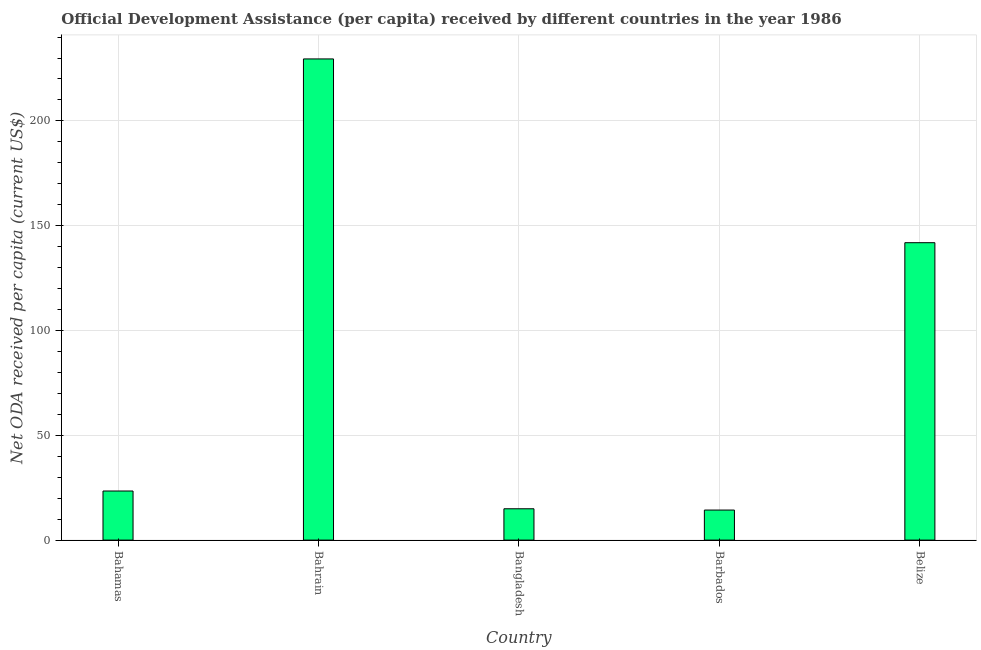Does the graph contain grids?
Your response must be concise. Yes. What is the title of the graph?
Offer a very short reply. Official Development Assistance (per capita) received by different countries in the year 1986. What is the label or title of the Y-axis?
Give a very brief answer. Net ODA received per capita (current US$). What is the net oda received per capita in Barbados?
Make the answer very short. 14.33. Across all countries, what is the maximum net oda received per capita?
Keep it short and to the point. 229.56. Across all countries, what is the minimum net oda received per capita?
Provide a succinct answer. 14.33. In which country was the net oda received per capita maximum?
Give a very brief answer. Bahrain. In which country was the net oda received per capita minimum?
Ensure brevity in your answer.  Barbados. What is the sum of the net oda received per capita?
Your answer should be compact. 424.14. What is the difference between the net oda received per capita in Bahamas and Barbados?
Ensure brevity in your answer.  9.08. What is the average net oda received per capita per country?
Give a very brief answer. 84.83. What is the median net oda received per capita?
Provide a short and direct response. 23.42. What is the ratio of the net oda received per capita in Barbados to that in Belize?
Your answer should be compact. 0.1. Is the net oda received per capita in Bangladesh less than that in Belize?
Offer a terse response. Yes. What is the difference between the highest and the second highest net oda received per capita?
Provide a short and direct response. 87.67. What is the difference between the highest and the lowest net oda received per capita?
Keep it short and to the point. 215.22. In how many countries, is the net oda received per capita greater than the average net oda received per capita taken over all countries?
Give a very brief answer. 2. How many countries are there in the graph?
Provide a succinct answer. 5. What is the difference between two consecutive major ticks on the Y-axis?
Make the answer very short. 50. Are the values on the major ticks of Y-axis written in scientific E-notation?
Provide a succinct answer. No. What is the Net ODA received per capita (current US$) of Bahamas?
Your answer should be very brief. 23.42. What is the Net ODA received per capita (current US$) in Bahrain?
Provide a short and direct response. 229.56. What is the Net ODA received per capita (current US$) of Bangladesh?
Your answer should be very brief. 14.95. What is the Net ODA received per capita (current US$) of Barbados?
Offer a very short reply. 14.33. What is the Net ODA received per capita (current US$) in Belize?
Offer a terse response. 141.89. What is the difference between the Net ODA received per capita (current US$) in Bahamas and Bahrain?
Offer a terse response. -206.14. What is the difference between the Net ODA received per capita (current US$) in Bahamas and Bangladesh?
Provide a succinct answer. 8.47. What is the difference between the Net ODA received per capita (current US$) in Bahamas and Barbados?
Make the answer very short. 9.08. What is the difference between the Net ODA received per capita (current US$) in Bahamas and Belize?
Make the answer very short. -118.47. What is the difference between the Net ODA received per capita (current US$) in Bahrain and Bangladesh?
Provide a succinct answer. 214.61. What is the difference between the Net ODA received per capita (current US$) in Bahrain and Barbados?
Offer a terse response. 215.22. What is the difference between the Net ODA received per capita (current US$) in Bahrain and Belize?
Your answer should be very brief. 87.67. What is the difference between the Net ODA received per capita (current US$) in Bangladesh and Barbados?
Offer a very short reply. 0.61. What is the difference between the Net ODA received per capita (current US$) in Bangladesh and Belize?
Your answer should be compact. -126.94. What is the difference between the Net ODA received per capita (current US$) in Barbados and Belize?
Your response must be concise. -127.55. What is the ratio of the Net ODA received per capita (current US$) in Bahamas to that in Bahrain?
Ensure brevity in your answer.  0.1. What is the ratio of the Net ODA received per capita (current US$) in Bahamas to that in Bangladesh?
Keep it short and to the point. 1.57. What is the ratio of the Net ODA received per capita (current US$) in Bahamas to that in Barbados?
Provide a short and direct response. 1.63. What is the ratio of the Net ODA received per capita (current US$) in Bahamas to that in Belize?
Your answer should be compact. 0.17. What is the ratio of the Net ODA received per capita (current US$) in Bahrain to that in Bangladesh?
Your answer should be compact. 15.36. What is the ratio of the Net ODA received per capita (current US$) in Bahrain to that in Barbados?
Keep it short and to the point. 16.02. What is the ratio of the Net ODA received per capita (current US$) in Bahrain to that in Belize?
Your response must be concise. 1.62. What is the ratio of the Net ODA received per capita (current US$) in Bangladesh to that in Barbados?
Your answer should be compact. 1.04. What is the ratio of the Net ODA received per capita (current US$) in Bangladesh to that in Belize?
Provide a short and direct response. 0.1. What is the ratio of the Net ODA received per capita (current US$) in Barbados to that in Belize?
Your answer should be compact. 0.1. 